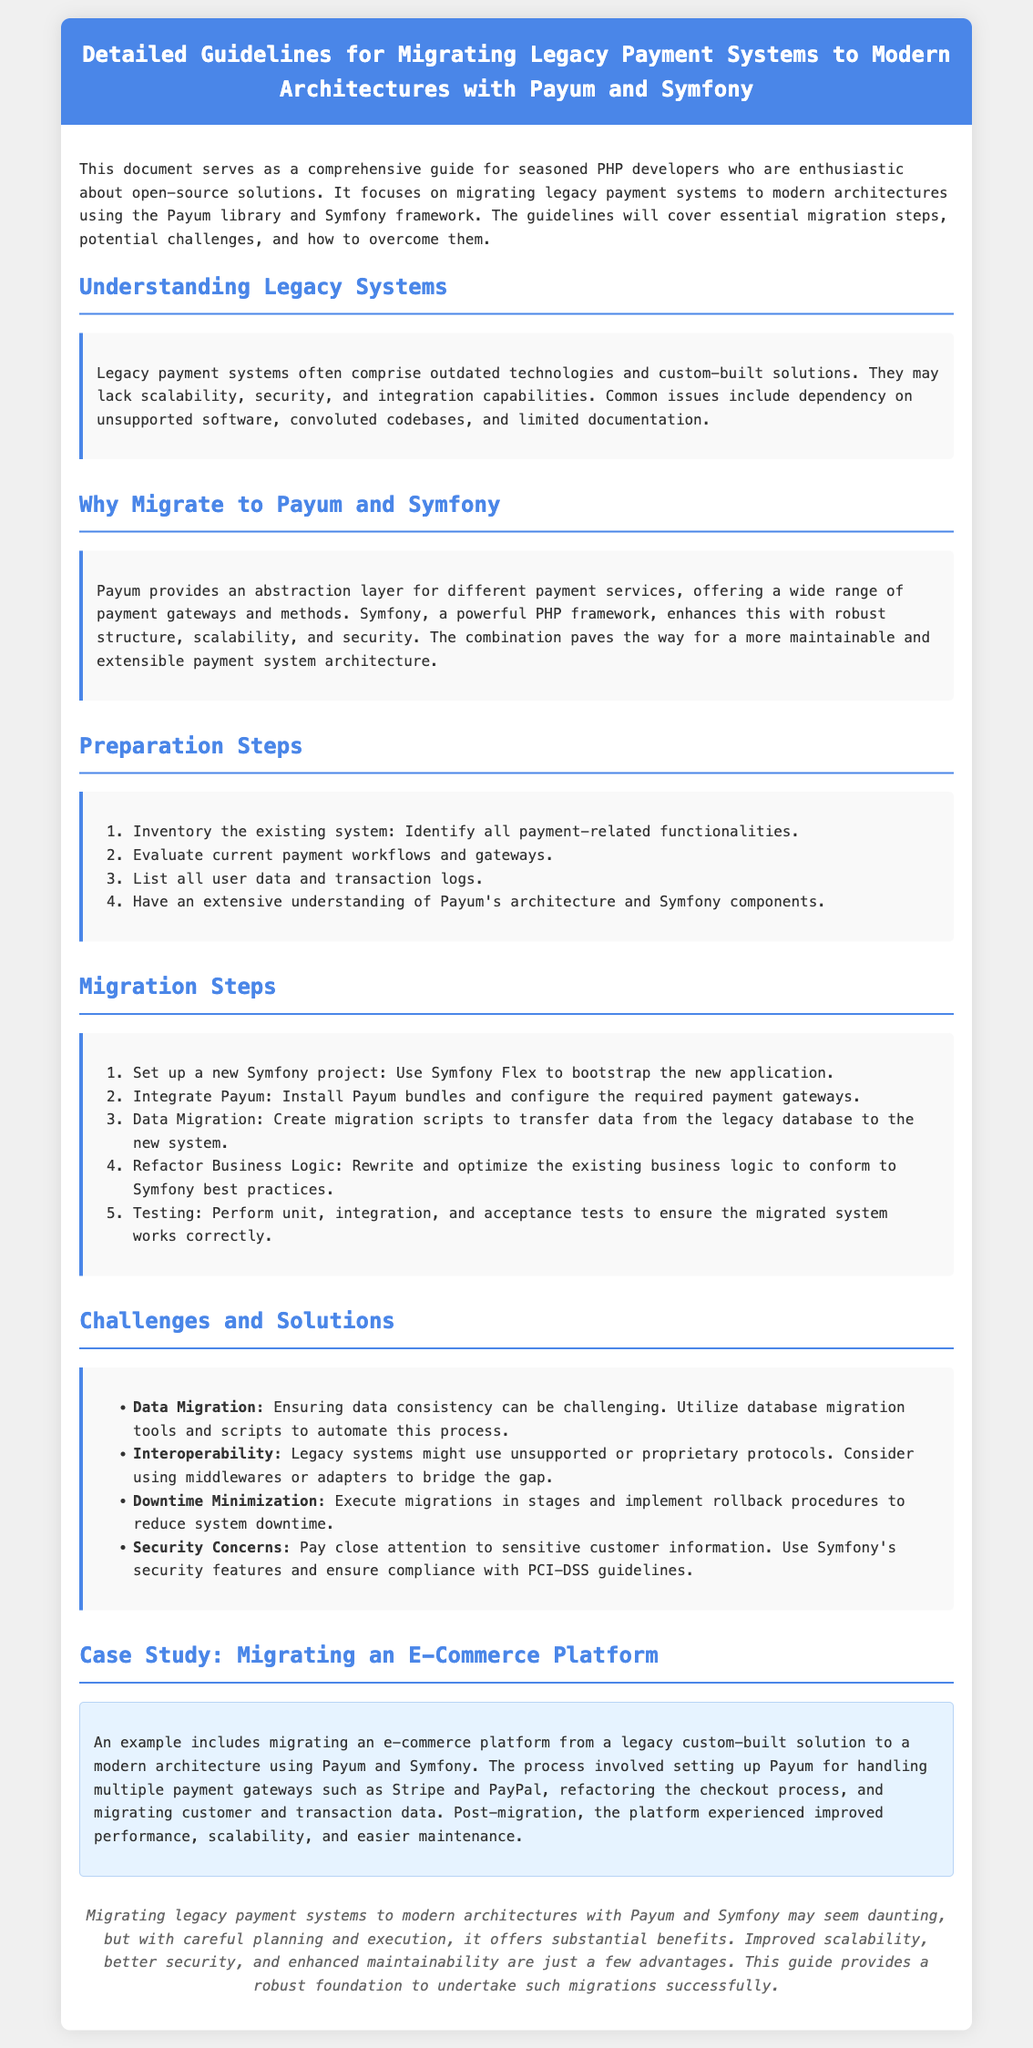What do legacy payment systems often lack? The document states that legacy payment systems may lack scalability, security, and integration capabilities.
Answer: Scalability, security, and integration capabilities What is one of the first preparation steps for migration? According to the document, one of the preparation steps is to inventory the existing system and identify all payment-related functionalities.
Answer: Inventory the existing system What does Payum provide? The document mentions that Payum provides an abstraction layer for different payment services.
Answer: Abstraction layer for different payment services How many steps are there in the migration process? The document lists a total of five steps in the migration process.
Answer: Five What is a potential challenge related to data migration? One challenge noted in the document is ensuring data consistency during the migration process.
Answer: Ensuring data consistency What guideline is suggested for minimizing downtime during migration? The document recommends executing migrations in stages and implementing rollback procedures to minimize downtime.
Answer: Execute migrations in stages Which payment gateways were mentioned in the case study? The case study highlights the use of multiple payment gateways, specifically Stripe and PayPal.
Answer: Stripe and PayPal What security feature is emphasized in the document? The document emphasizes using Symfony's security features and ensuring compliance with PCI-DSS guidelines as a security measure.
Answer: Symfony's security features and PCI-DSS compliance What type of architecture are legacy payment systems suggested to migrate to? The document suggests migrating to modern architectures using Payum and Symfony.
Answer: Modern architectures using Payum and Symfony 